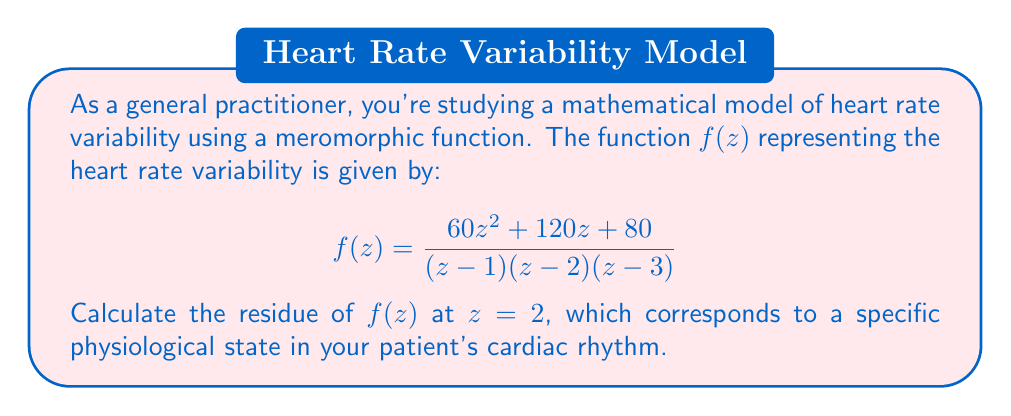Can you answer this question? To calculate the residue of $f(z)$ at $z=2$, we'll use the following method:

1) First, note that $z=2$ is a simple pole of $f(z)$, as it appears as a linear factor in the denominator.

2) For a simple pole at $z=a$, the residue is given by:

   $$\text{Res}(f,a) = \lim_{z \to a} (z-a)f(z)$$

3) In our case, $a=2$, so we need to calculate:

   $$\text{Res}(f,2) = \lim_{z \to 2} (z-2)f(z)$$

4) Let's substitute the function:

   $$\text{Res}(f,2) = \lim_{z \to 2} (z-2) \cdot \frac{60z^2 + 120z + 80}{(z-1)(z-2)(z-3)}$$

5) The $(z-2)$ terms cancel out:

   $$\text{Res}(f,2) = \lim_{z \to 2} \frac{60z^2 + 120z + 80}{(z-1)(z-3)}$$

6) Now we can directly substitute $z=2$:

   $$\text{Res}(f,2) = \frac{60(2)^2 + 120(2) + 80}{(2-1)(2-3)}$$

7) Simplify:

   $$\text{Res}(f,2) = \frac{240 + 240 + 80}{1 \cdot (-1)} = \frac{560}{-1} = -560$$

Therefore, the residue of $f(z)$ at $z=2$ is $-560$.
Answer: $-560$ 